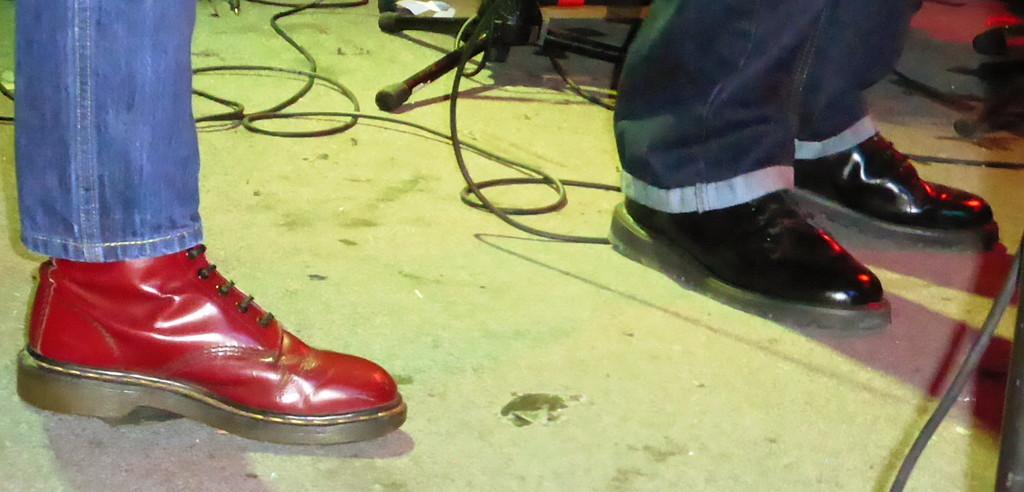In one or two sentences, can you explain what this image depicts? Here in this picture we can see legs of persons present on the floor and we can see shoes on the legs and on the floor we can see cable wires and a stand present. 